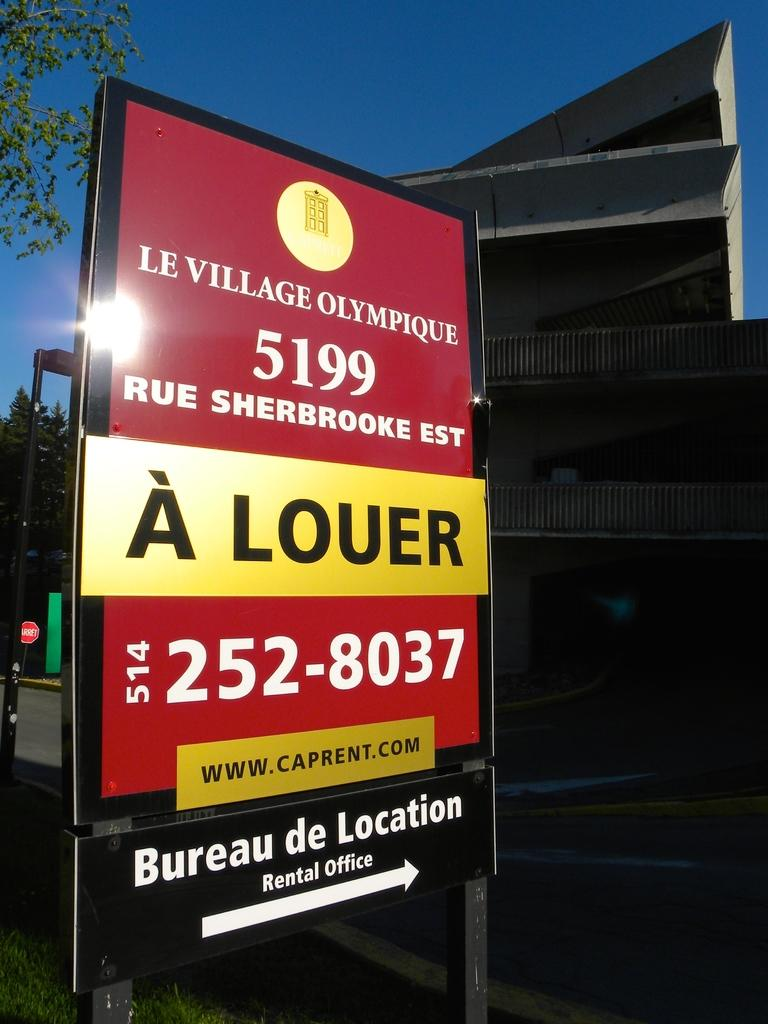Provide a one-sentence caption for the provided image. A sign in French shows the way to the rental office for the Olympic Village. 